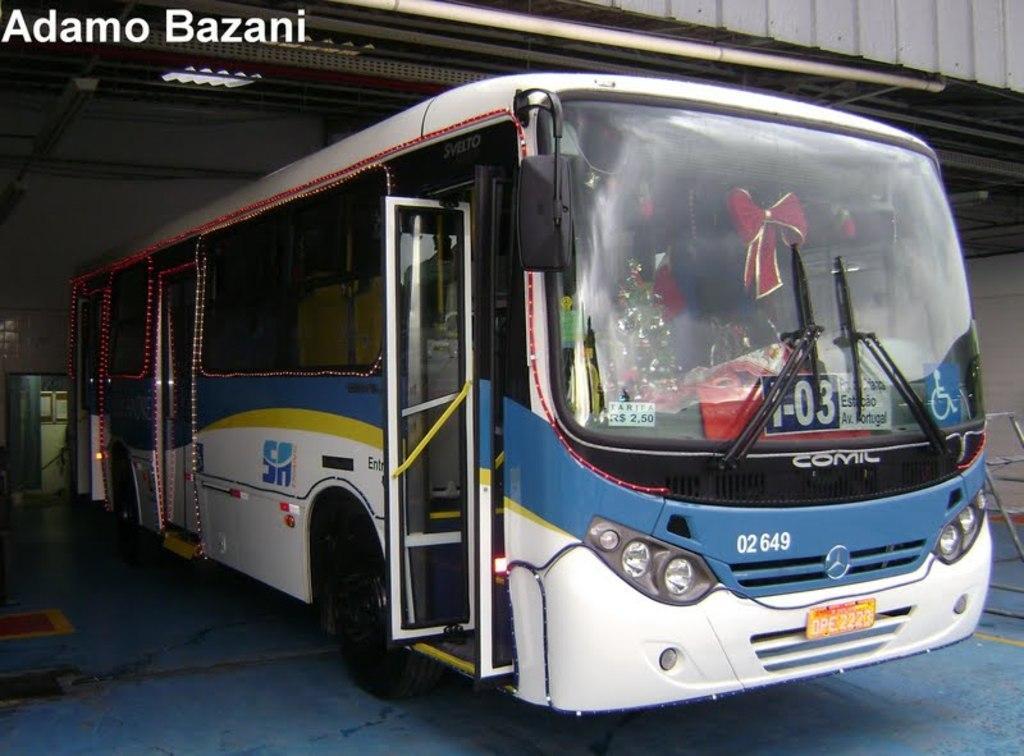Can you describe this image briefly? In this image there is a bus under a roof. Left side there is a ladder on the floor. 